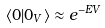<formula> <loc_0><loc_0><loc_500><loc_500>\langle 0 | 0 _ { V } \rangle \approx e ^ { - E V }</formula> 